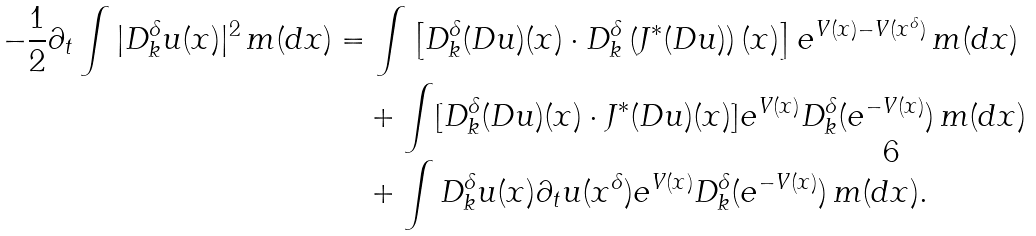Convert formula to latex. <formula><loc_0><loc_0><loc_500><loc_500>- \frac { 1 } { 2 } \partial _ { t } \int | D _ { k } ^ { \delta } u ( x ) | ^ { 2 } \, m ( d x ) & = \int \left [ D _ { k } ^ { \delta } ( D u ) ( x ) \cdot D _ { k } ^ { \delta } \left ( J ^ { * } ( D u ) \right ) ( x ) \right ] e ^ { V ( x ) - V ( x ^ { \delta } ) } \, m ( d x ) \\ & \quad + \int [ D _ { k } ^ { \delta } ( D u ) ( x ) \cdot J ^ { * } ( D u ) ( x ) ] e ^ { V ( x ) } D _ { k } ^ { \delta } ( e ^ { - V ( x ) } ) \, m ( d x ) \\ & \quad + \int D _ { k } ^ { \delta } u ( x ) \partial _ { t } u ( x ^ { \delta } ) e ^ { V ( x ) } D _ { k } ^ { \delta } ( e ^ { - V ( x ) } ) \, m ( d x ) .</formula> 